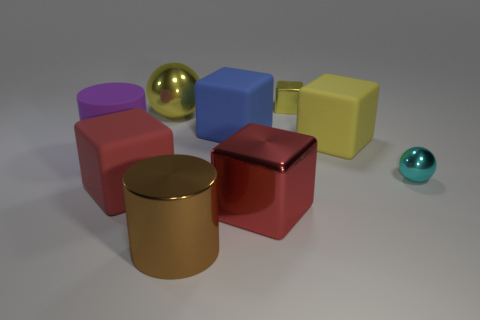How would you describe the colors of the objects? The objects in the image exhibit a variety of colors, including vibrant shades like pink, red, and blue, as well as muted tones found in the brown cylinder and the subdued gold sphere. The colors are well balanced, contributing to a harmonious composition. 